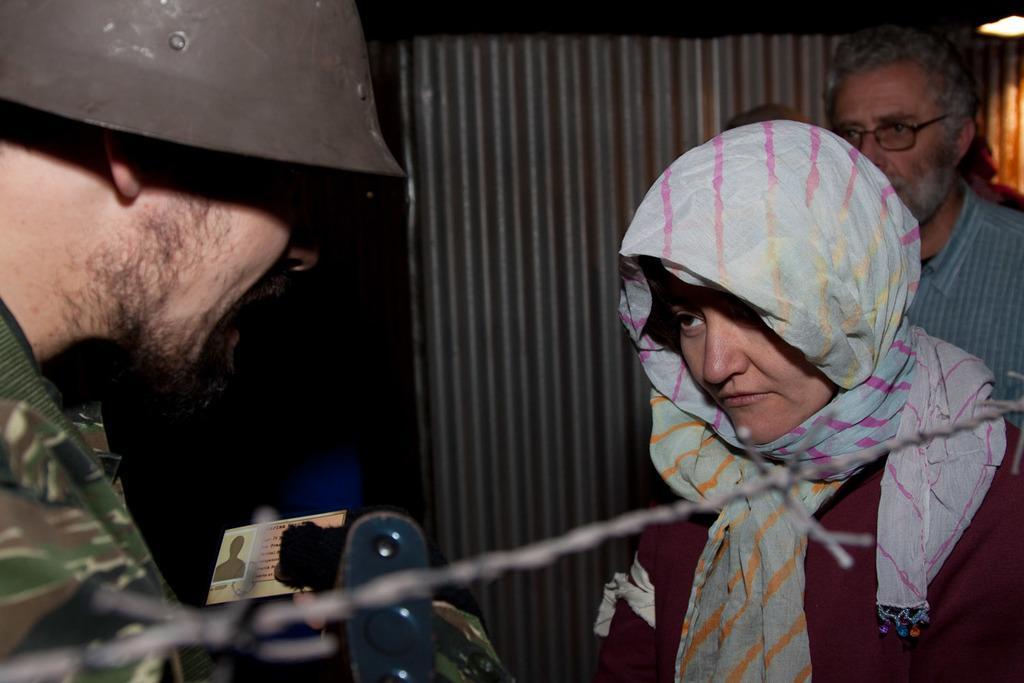Can you describe this image briefly? In this image I see 2 men and a woman and I see that this man is wearing a helmet and I see the fencing wire over here and in the background I see the light over here. 